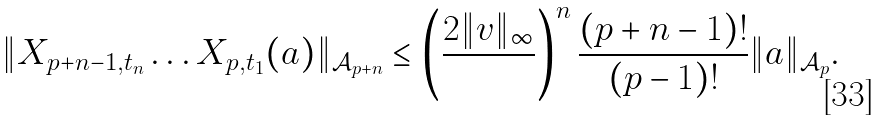<formula> <loc_0><loc_0><loc_500><loc_500>\| X _ { p + n - 1 , t _ { n } } \dots X _ { p , t _ { 1 } } ( a ) \| _ { \mathcal { A } _ { p + n } } \leq \left ( \frac { 2 \| v \| _ { \infty } } { } \right ) ^ { n } \frac { ( p + n - 1 ) ! } { ( p - 1 ) ! } \| a \| _ { \mathcal { A } _ { p } } .</formula> 